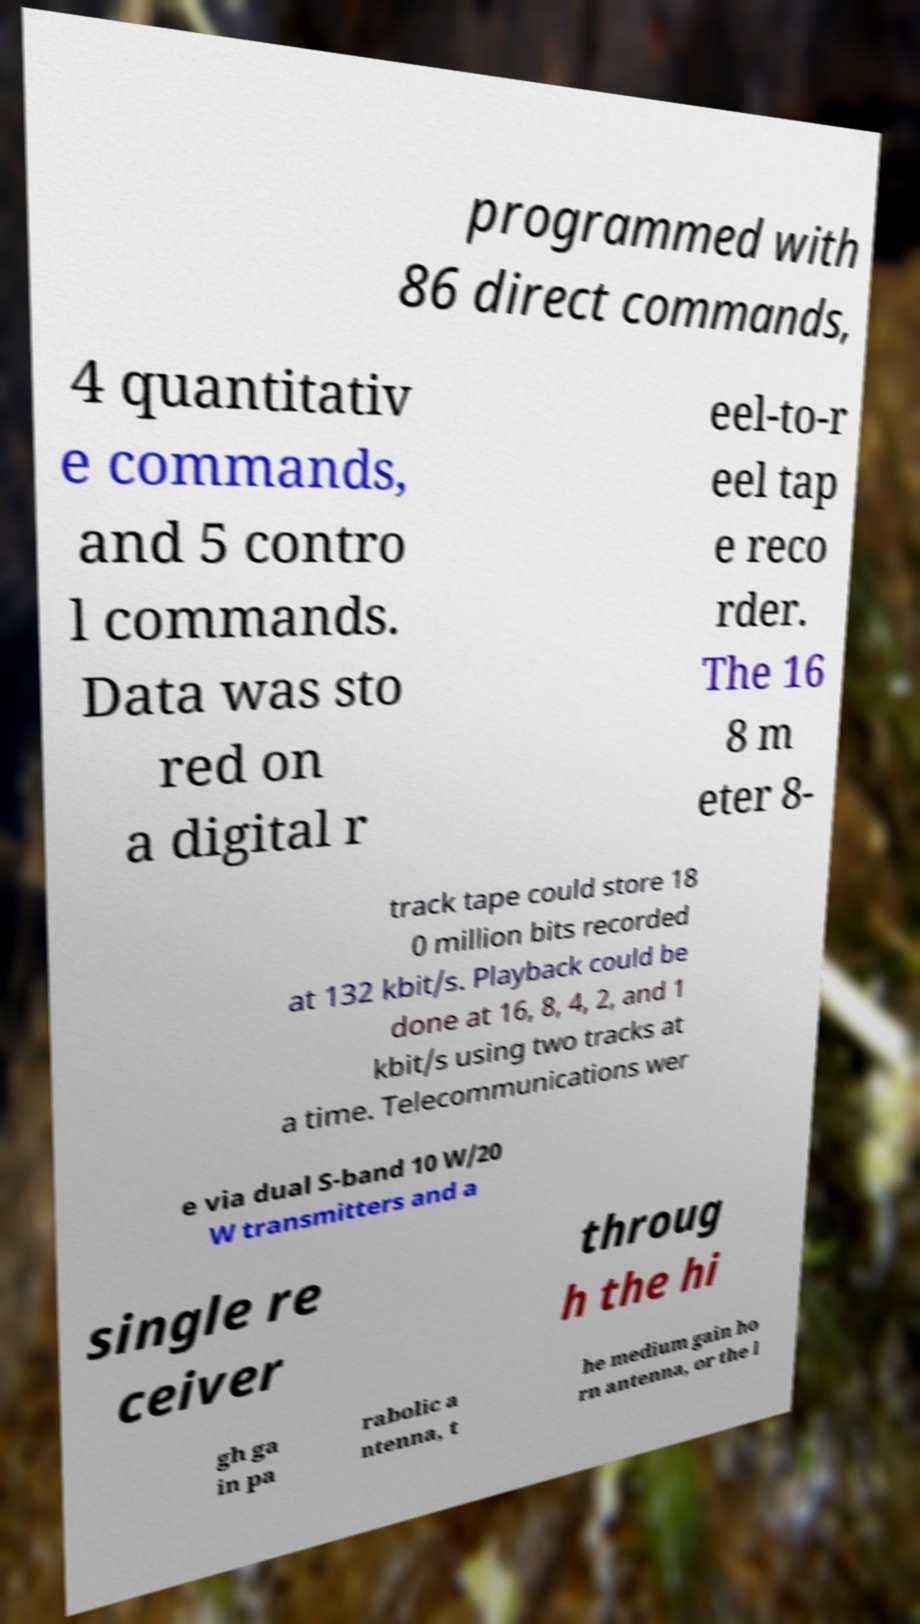Please read and relay the text visible in this image. What does it say? programmed with 86 direct commands, 4 quantitativ e commands, and 5 contro l commands. Data was sto red on a digital r eel-to-r eel tap e reco rder. The 16 8 m eter 8- track tape could store 18 0 million bits recorded at 132 kbit/s. Playback could be done at 16, 8, 4, 2, and 1 kbit/s using two tracks at a time. Telecommunications wer e via dual S-band 10 W/20 W transmitters and a single re ceiver throug h the hi gh ga in pa rabolic a ntenna, t he medium gain ho rn antenna, or the l 